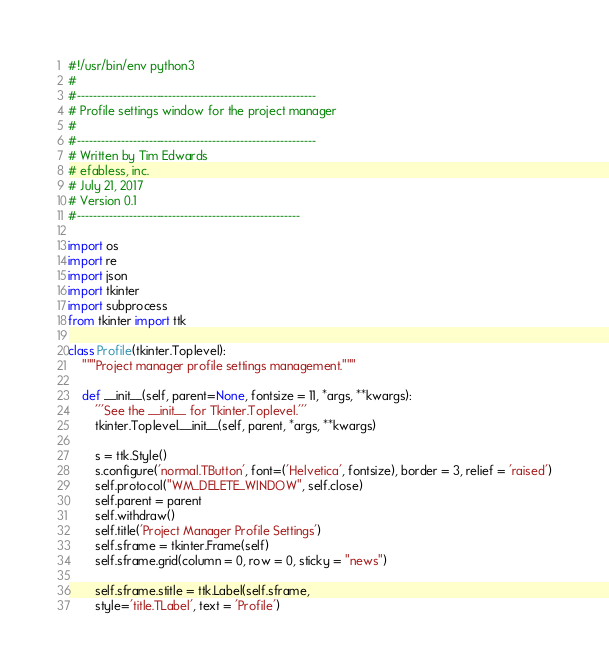Convert code to text. <code><loc_0><loc_0><loc_500><loc_500><_Python_>#!/usr/bin/env python3
#
#------------------------------------------------------------
# Profile settings window for the project manager
#
#------------------------------------------------------------
# Written by Tim Edwards
# efabless, inc.
# July 21, 2017
# Version 0.1
#--------------------------------------------------------

import os
import re
import json
import tkinter
import subprocess
from tkinter import ttk

class Profile(tkinter.Toplevel):
    """Project manager profile settings management."""

    def __init__(self, parent=None, fontsize = 11, *args, **kwargs):
        '''See the __init__ for Tkinter.Toplevel.'''
        tkinter.Toplevel.__init__(self, parent, *args, **kwargs)

        s = ttk.Style()
        s.configure('normal.TButton', font=('Helvetica', fontsize), border = 3, relief = 'raised')
        self.protocol("WM_DELETE_WINDOW", self.close)
        self.parent = parent
        self.withdraw()
        self.title('Project Manager Profile Settings')
        self.sframe = tkinter.Frame(self)
        self.sframe.grid(column = 0, row = 0, sticky = "news")

        self.sframe.stitle = ttk.Label(self.sframe,
		style='title.TLabel', text = 'Profile')</code> 